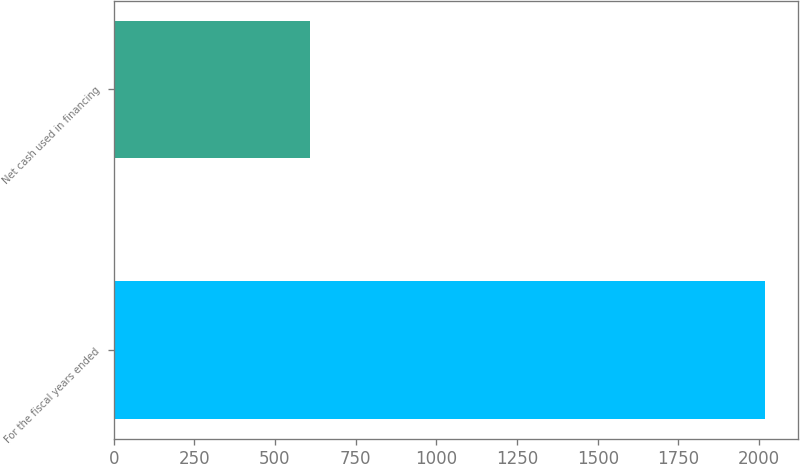Convert chart to OTSL. <chart><loc_0><loc_0><loc_500><loc_500><bar_chart><fcel>For the fiscal years ended<fcel>Net cash used in financing<nl><fcel>2019<fcel>610<nl></chart> 